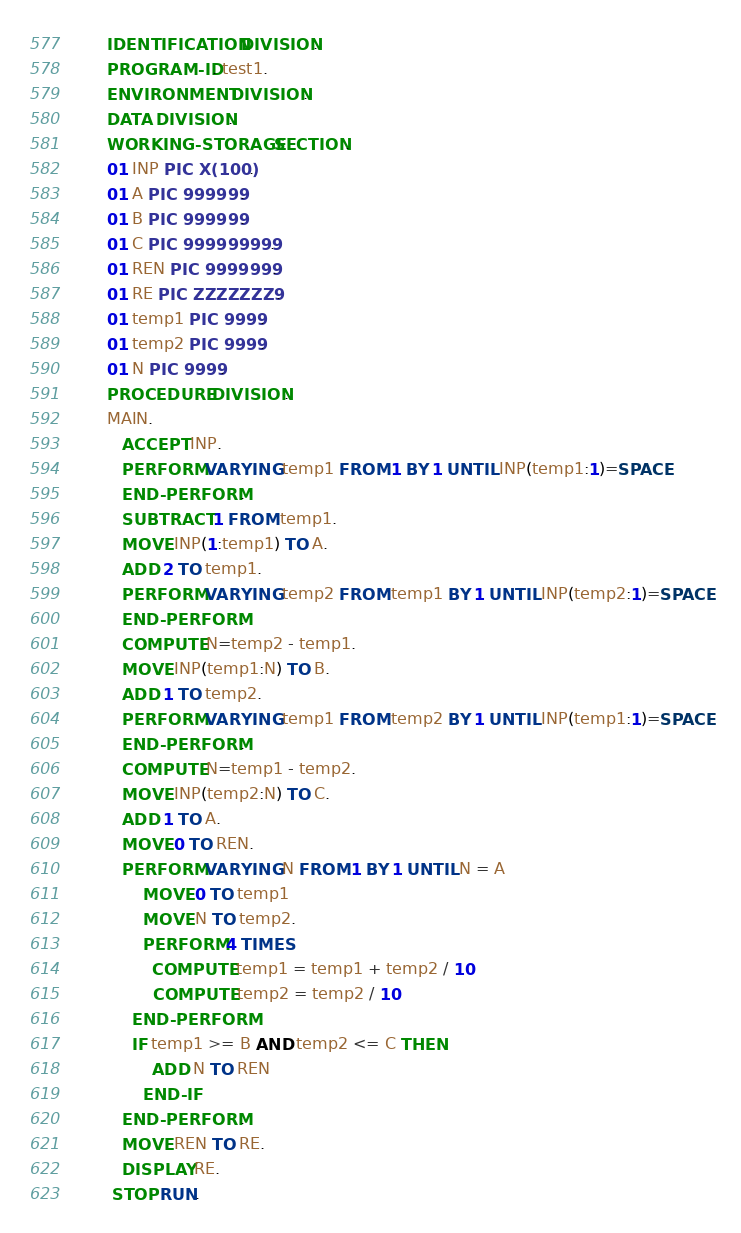<code> <loc_0><loc_0><loc_500><loc_500><_COBOL_>       IDENTIFICATION DIVISION.
       PROGRAM-ID. test1.
       ENVIRONMENT DIVISION.
       DATA DIVISION.
       WORKING-STORAGE SECTION.
       01 INP PIC X(100).
       01 A PIC 999999.
       01 B PIC 999999.
       01 C PIC 999999999.
       01 REN PIC 9999999.
       01 RE PIC ZZZZZZZ9.
       01 temp1 PIC 9999.
       01 temp2 PIC 9999.
       01 N PIC 9999.
       PROCEDURE DIVISION.
       MAIN.
       	ACCEPT INP.
      	PERFORM VARYING temp1 FROM 1 BY 1 UNTIL INP(temp1:1)=SPACE
      	END-PERFORM.
      	SUBTRACT 1 FROM temp1.
      	MOVE INP(1:temp1) TO A.
      	ADD 2 TO temp1.
      	PERFORM VARYING temp2 FROM temp1 BY 1 UNTIL INP(temp2:1)=SPACE
      	END-PERFORM.
      	COMPUTE N=temp2 - temp1.
      	MOVE INP(temp1:N) TO B.
      	ADD 1 TO temp2.
      	PERFORM VARYING temp1 FROM temp2 BY 1 UNTIL INP(temp1:1)=SPACE
      	END-PERFORM.
      	COMPUTE N=temp1 - temp2.
      	MOVE INP(temp2:N) TO C.
      	ADD 1 TO A.
      	MOVE 0 TO REN.
      	PERFORM VARYING N FROM 1 BY 1 UNTIL N = A
      		MOVE 0 TO temp1
      		MOVE N TO temp2.
      		PERFORM 4 TIMES
      			COMPUTE temp1 = temp1 + temp2 / 10
      			COMPUTE temp2 = temp2 / 10
			END-PERFORM
      		IF temp1 >= B AND temp2 <= C THEN
      			ADD N TO REN
      		END-IF
      	END-PERFORM.
      	MOVE REN TO RE.
      	DISPLAY RE.
        STOP RUN.

</code> 